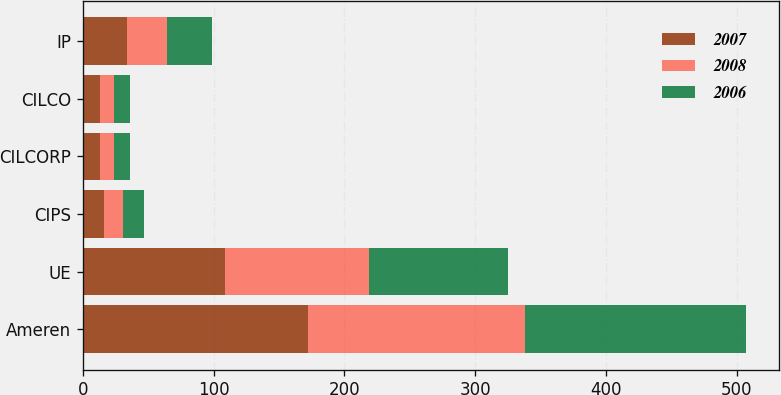<chart> <loc_0><loc_0><loc_500><loc_500><stacked_bar_chart><ecel><fcel>Ameren<fcel>UE<fcel>CIPS<fcel>CILCORP<fcel>CILCO<fcel>IP<nl><fcel>2007<fcel>172<fcel>109<fcel>16<fcel>13<fcel>13<fcel>34<nl><fcel>2008<fcel>166<fcel>110<fcel>15<fcel>11<fcel>11<fcel>30<nl><fcel>2006<fcel>169<fcel>106<fcel>16<fcel>12<fcel>12<fcel>35<nl></chart> 